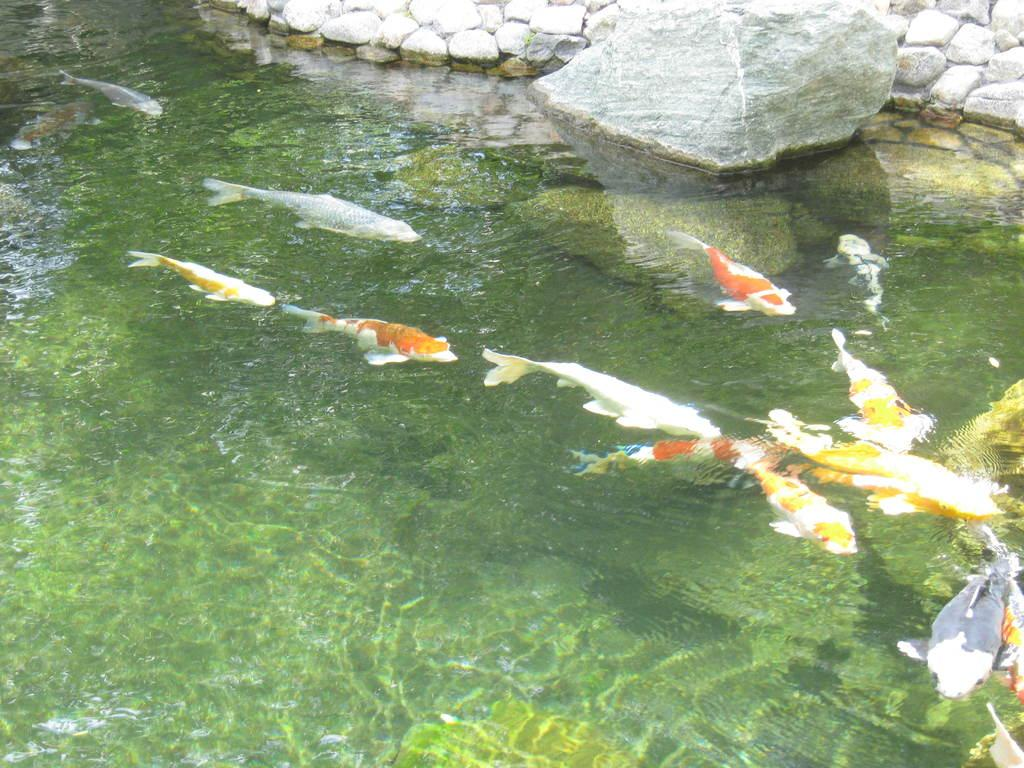What is the primary element in the image? There is water in the image. What can be found within the water? There are fish in the water. What type of natural feature is visible in the background of the image? There are rocks in the background of the image. What type of representative is wearing a stamp and veil in the image? There is no representative, stamp, or veil present in the image; it features water with fish and rocks in the background. 